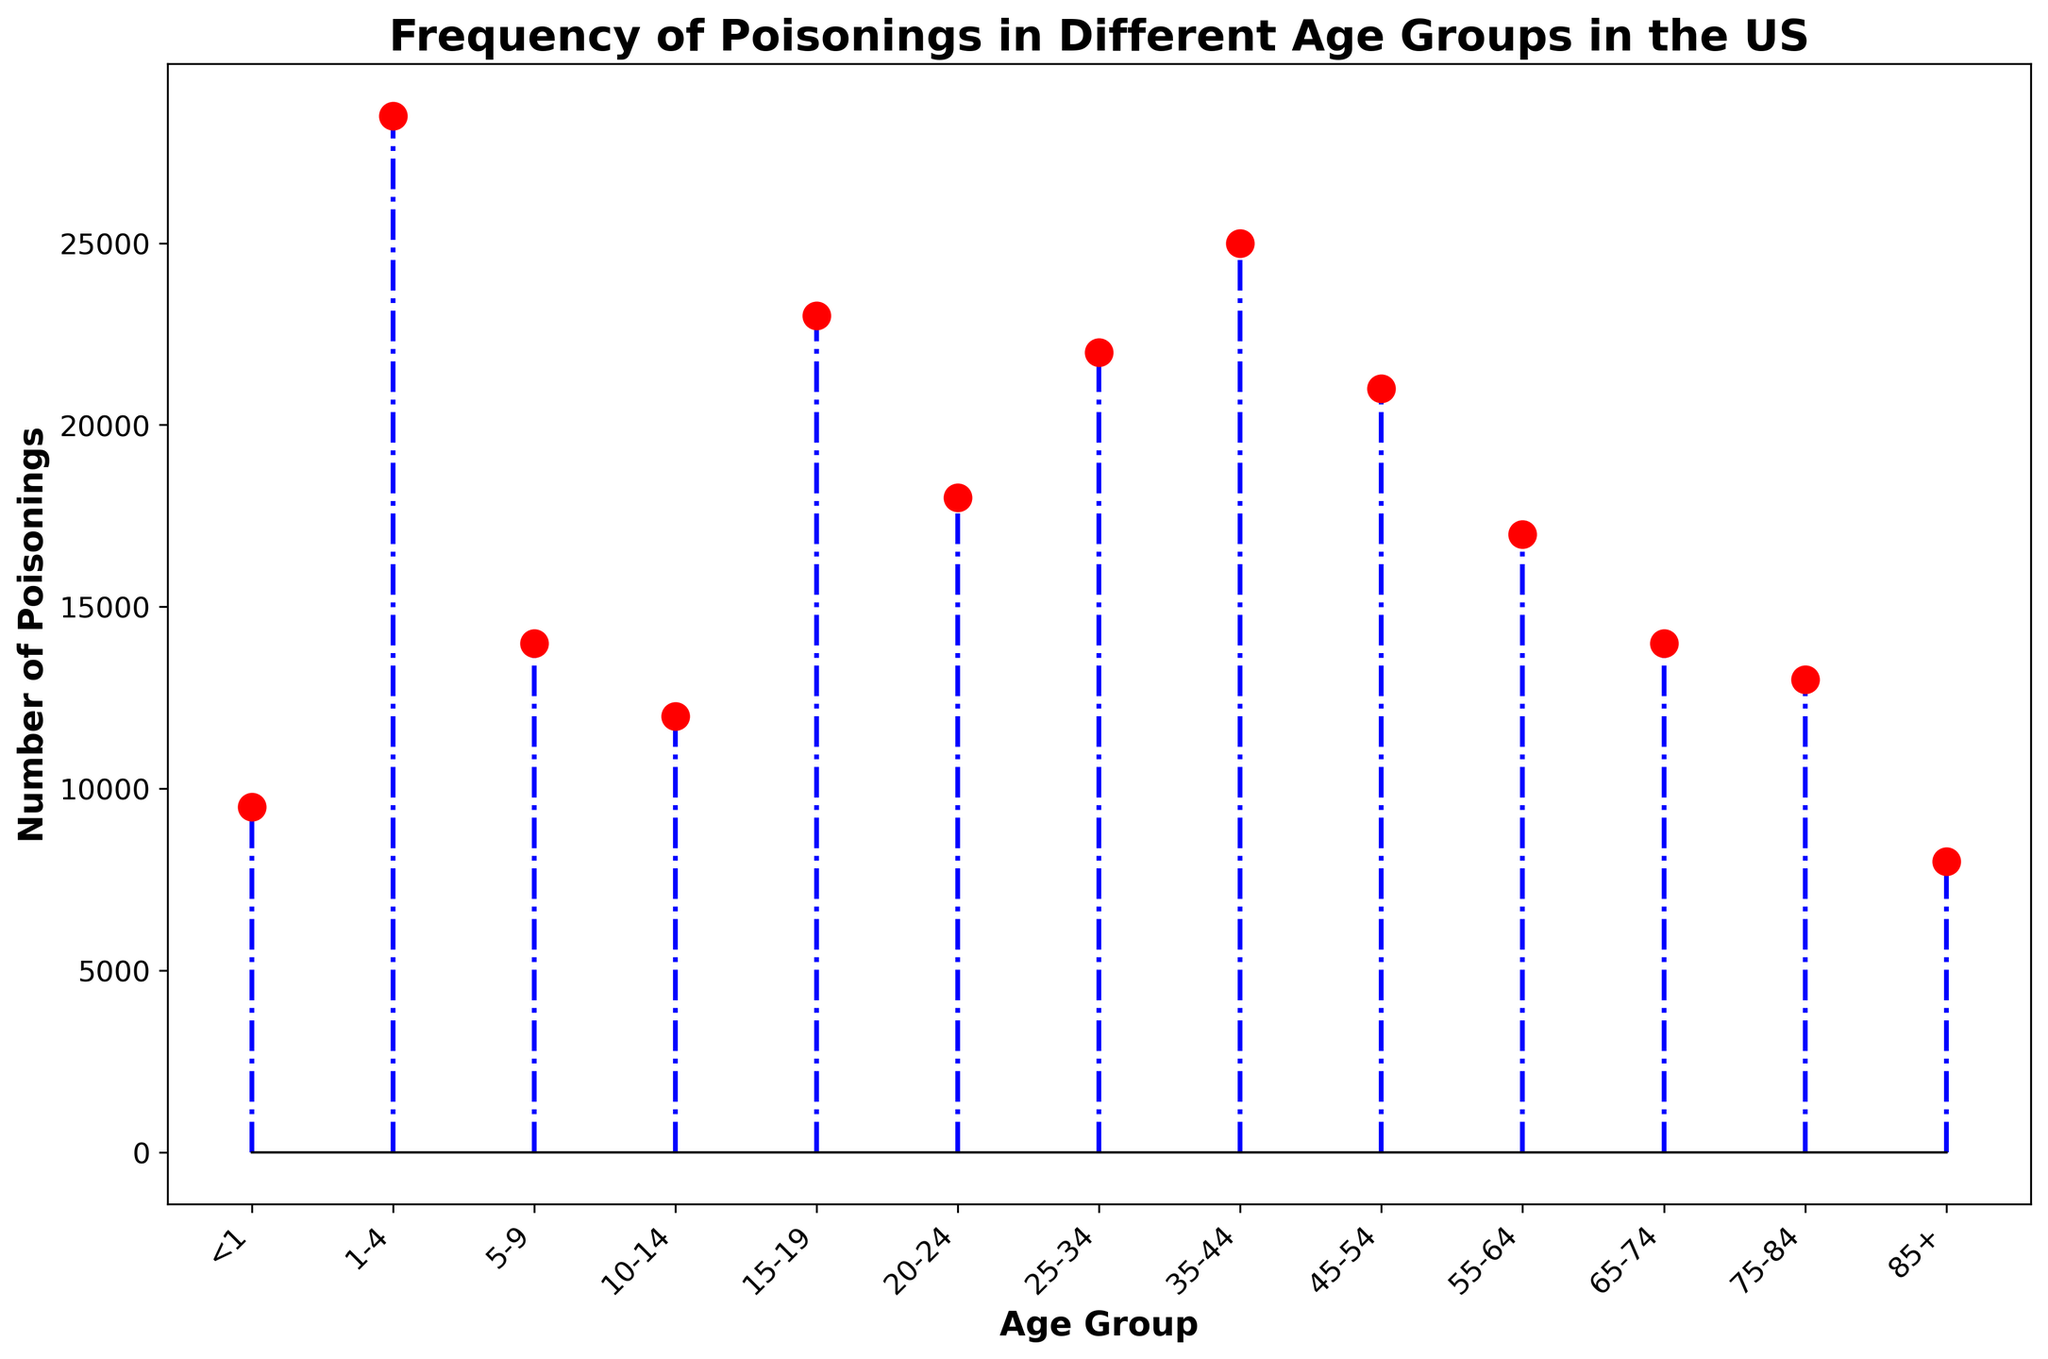Which age group has the highest number of poisonings? By examining the heights of the markers on the stem plot, the tallest marker corresponds to the age group 1-4. Hence, this age group has the highest number of poisonings.
Answer: 1-4 How does the number of poisonings for the 10-14 age group compare to the 65-74 age group? By comparing the heights of the markers for the 10-14 and 65-74 age groups, the marker for 10-14 is higher than the one for 65-74. Therefore, the number of poisonings is higher in the 10-14 age group.
Answer: 10-14 is higher What is the combined number of poisonings for the age groups 20-24 and 25-34? Adding the values for the 20-24 and 25-34 age groups, which are 18000 and 22000 respectively, gives a total of 18000 + 22000 = 40000.
Answer: 40000 What is the difference in the number of poisonings between the age groups <1 and 85+? Subtracting the number of poisonings in the 85+ age group from the <1 age group, we get 9500 - 8000 = 1500.
Answer: 1500 Which age group has the lowest number of poisonings? By looking at the stem plot, the shortest marker corresponds to the age group 85+. Thus, this age group has the lowest number of poisonings.
Answer: 85+ What is the average number of poisonings across all age groups? To find the average, sum all the values and divide by the number of age groups. Sum = 9500 + 28500 + 14000 + 12000 + 23000 + 18000 + 22000 + 25000 + 21000 + 17000 + 14000 + 13000 + 8000 = 245000. There are 13 age groups, so average = 245000 / 13 ≈ 18846.
Answer: 18846 How many age groups have more than 20000 poisonings? By counting the markers that are taller than the 20000 value on the y-axis, we find there are 6 age groups with more than 20000 poisonings: 1-4, 15-19, 25-34, 35-44, 45-54.
Answer: 5 By how much does the number of poisonings in the 45-54 age group exceed the 55-64 age group? Subtracting the number of poisonings in the 55-64 age group from the 45-54 age group, we get 21000 - 17000 = 4000.
Answer: 4000 